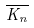<formula> <loc_0><loc_0><loc_500><loc_500>\overline { K _ { n } }</formula> 